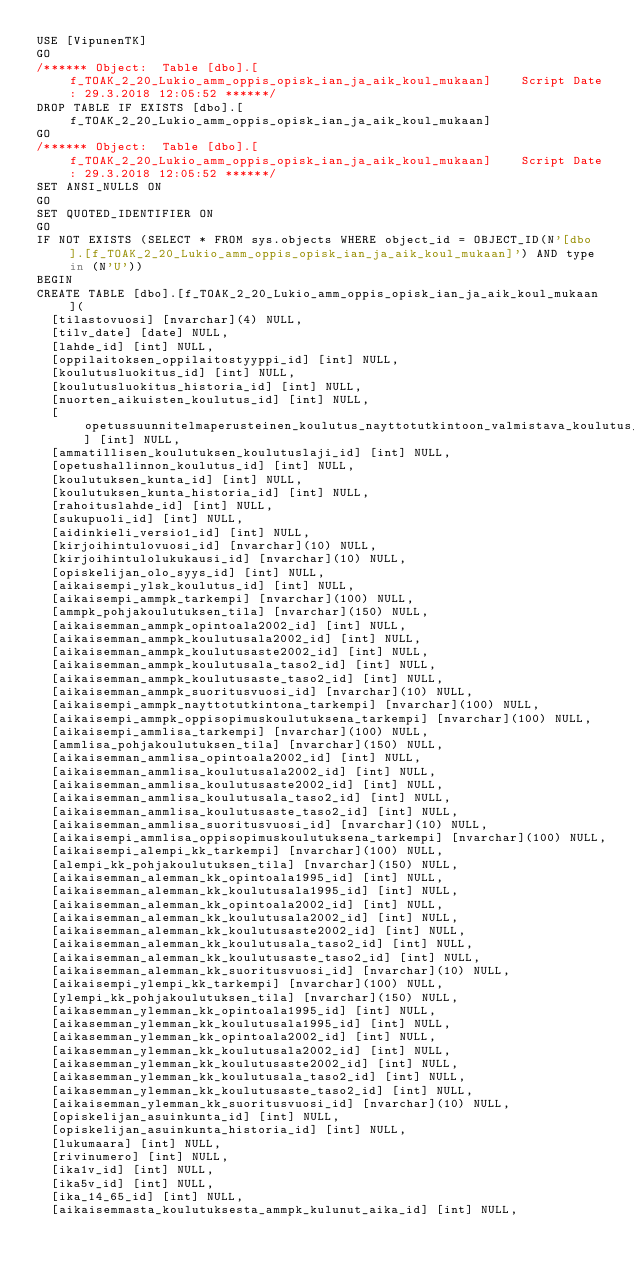<code> <loc_0><loc_0><loc_500><loc_500><_SQL_>USE [VipunenTK]
GO
/****** Object:  Table [dbo].[f_TOAK_2_20_Lukio_amm_oppis_opisk_ian_ja_aik_koul_mukaan]    Script Date: 29.3.2018 12:05:52 ******/
DROP TABLE IF EXISTS [dbo].[f_TOAK_2_20_Lukio_amm_oppis_opisk_ian_ja_aik_koul_mukaan]
GO
/****** Object:  Table [dbo].[f_TOAK_2_20_Lukio_amm_oppis_opisk_ian_ja_aik_koul_mukaan]    Script Date: 29.3.2018 12:05:52 ******/
SET ANSI_NULLS ON
GO
SET QUOTED_IDENTIFIER ON
GO
IF NOT EXISTS (SELECT * FROM sys.objects WHERE object_id = OBJECT_ID(N'[dbo].[f_TOAK_2_20_Lukio_amm_oppis_opisk_ian_ja_aik_koul_mukaan]') AND type in (N'U'))
BEGIN
CREATE TABLE [dbo].[f_TOAK_2_20_Lukio_amm_oppis_opisk_ian_ja_aik_koul_mukaan](
	[tilastovuosi] [nvarchar](4) NULL,
	[tilv_date] [date] NULL,
	[lahde_id] [int] NULL,
	[oppilaitoksen_oppilaitostyyppi_id] [int] NULL,
	[koulutusluokitus_id] [int] NULL,
	[koulutusluokitus_historia_id] [int] NULL,
	[nuorten_aikuisten_koulutus_id] [int] NULL,
	[opetussuunnitelmaperusteinen_koulutus_nayttotutkintoon_valmistava_koulutus_id] [int] NULL,
	[ammatillisen_koulutuksen_koulutuslaji_id] [int] NULL,
	[opetushallinnon_koulutus_id] [int] NULL,
	[koulutuksen_kunta_id] [int] NULL,
	[koulutuksen_kunta_historia_id] [int] NULL,
	[rahoituslahde_id] [int] NULL,
	[sukupuoli_id] [int] NULL,
	[aidinkieli_versio1_id] [int] NULL,
	[kirjoihintulovuosi_id] [nvarchar](10) NULL,
	[kirjoihintulolukukausi_id] [nvarchar](10) NULL,
	[opiskelijan_olo_syys_id] [int] NULL,
	[aikaisempi_ylsk_koulutus_id] [int] NULL,
	[aikaisempi_ammpk_tarkempi] [nvarchar](100) NULL,
	[ammpk_pohjakoulutuksen_tila] [nvarchar](150) NULL,
	[aikaisemman_ammpk_opintoala2002_id] [int] NULL,
	[aikaisemman_ammpk_koulutusala2002_id] [int] NULL,
	[aikaisemman_ammpk_koulutusaste2002_id] [int] NULL,
	[aikaisemman_ammpk_koulutusala_taso2_id] [int] NULL,
	[aikaisemman_ammpk_koulutusaste_taso2_id] [int] NULL,
	[aikaisemman_ammpk_suoritusvuosi_id] [nvarchar](10) NULL,
	[aikaisempi_ammpk_nayttotutkintona_tarkempi] [nvarchar](100) NULL,
	[aikaisempi_ammpk_oppisopimuskoulutuksena_tarkempi] [nvarchar](100) NULL,
	[aikaisempi_ammlisa_tarkempi] [nvarchar](100) NULL,
	[ammlisa_pohjakoulutuksen_tila] [nvarchar](150) NULL,
	[aikaisemman_ammlisa_opintoala2002_id] [int] NULL,
	[aikaisemman_ammlisa_koulutusala2002_id] [int] NULL,
	[aikaisemman_ammlisa_koulutusaste2002_id] [int] NULL,
	[aikaisemman_ammlisa_koulutusala_taso2_id] [int] NULL,
	[aikaisemman_ammlisa_koulutusaste_taso2_id] [int] NULL,
	[aikaisemman_ammlisa_suoritusvuosi_id] [nvarchar](10) NULL,
	[aikaisempi_ammlisa_oppisopimuskoulutuksena_tarkempi] [nvarchar](100) NULL,
	[aikaisempi_alempi_kk_tarkempi] [nvarchar](100) NULL,
	[alempi_kk_pohjakoulutuksen_tila] [nvarchar](150) NULL,
	[aikaisemman_alemman_kk_opintoala1995_id] [int] NULL,
	[aikaisemman_alemman_kk_koulutusala1995_id] [int] NULL,
	[aikaisemman_alemman_kk_opintoala2002_id] [int] NULL,
	[aikaisemman_alemman_kk_koulutusala2002_id] [int] NULL,
	[aikaisemman_alemman_kk_koulutusaste2002_id] [int] NULL,
	[aikaisemman_alemman_kk_koulutusala_taso2_id] [int] NULL,
	[aikaisemman_alemman_kk_koulutusaste_taso2_id] [int] NULL,
	[aikaisemman_alemman_kk_suoritusvuosi_id] [nvarchar](10) NULL,
	[aikaisempi_ylempi_kk_tarkempi] [nvarchar](100) NULL,
	[ylempi_kk_pohjakoulutuksen_tila] [nvarchar](150) NULL,
	[aikasemman_ylemman_kk_opintoala1995_id] [int] NULL,
	[aikasemman_ylemman_kk_koulutusala1995_id] [int] NULL,
	[aikasemman_ylemman_kk_opintoala2002_id] [int] NULL,
	[aikasemman_ylemman_kk_koulutusala2002_id] [int] NULL,
	[aikasemman_ylemman_kk_koulutusaste2002_id] [int] NULL,
	[aikasemman_ylemman_kk_koulutusala_taso2_id] [int] NULL,
	[aikasemman_ylemman_kk_koulutusaste_taso2_id] [int] NULL,
	[aikaisemman_ylemman_kk_suoritusvuosi_id] [nvarchar](10) NULL,
	[opiskelijan_asuinkunta_id] [int] NULL,
	[opiskelijan_asuinkunta_historia_id] [int] NULL,
	[lukumaara] [int] NULL,
	[rivinumero] [int] NULL,
	[ika1v_id] [int] NULL,
	[ika5v_id] [int] NULL,
	[ika_14_65_id] [int] NULL,
	[aikaisemmasta_koulutuksesta_ammpk_kulunut_aika_id] [int] NULL,</code> 